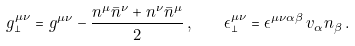<formula> <loc_0><loc_0><loc_500><loc_500>g _ { \perp } ^ { \mu \nu } = g ^ { \mu \nu } - \frac { n ^ { \mu } \bar { n } ^ { \nu } + n ^ { \nu } \bar { n } ^ { \mu } } { 2 } \, , \quad \epsilon _ { \perp } ^ { \mu \nu } = \epsilon ^ { \mu \nu \alpha \beta } \, v _ { \alpha } n _ { \beta } \, .</formula> 